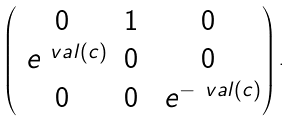<formula> <loc_0><loc_0><loc_500><loc_500>\begin{pmatrix} 0 & 1 & 0 \\ \ e ^ { \ v a l ( c ) } & 0 & 0 \\ 0 & 0 & \ e ^ { - \ v a l ( c ) } \end{pmatrix} .</formula> 